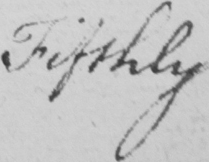Can you tell me what this handwritten text says? Fifthly 